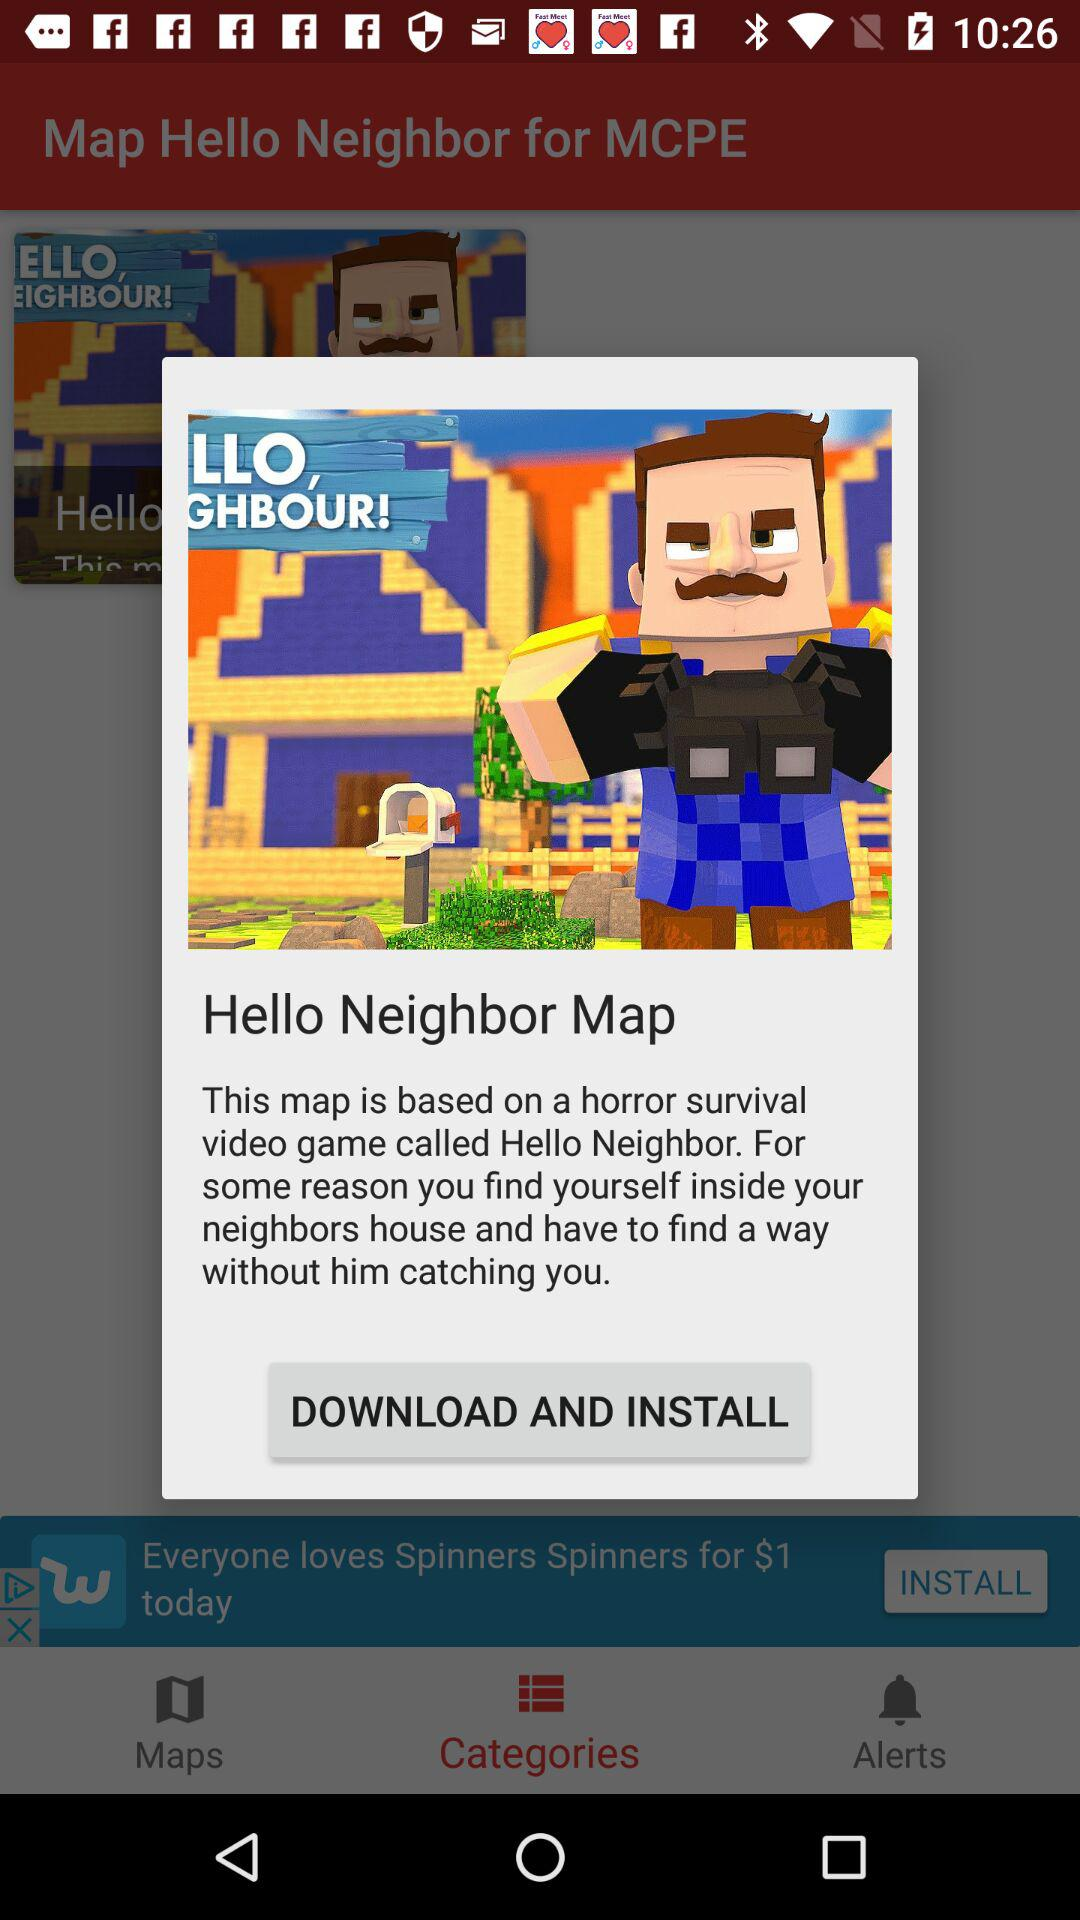What is the application name? The names of the applications are "Map Hello Neighbor for MCPE" and "Hello Neighbor Map". 